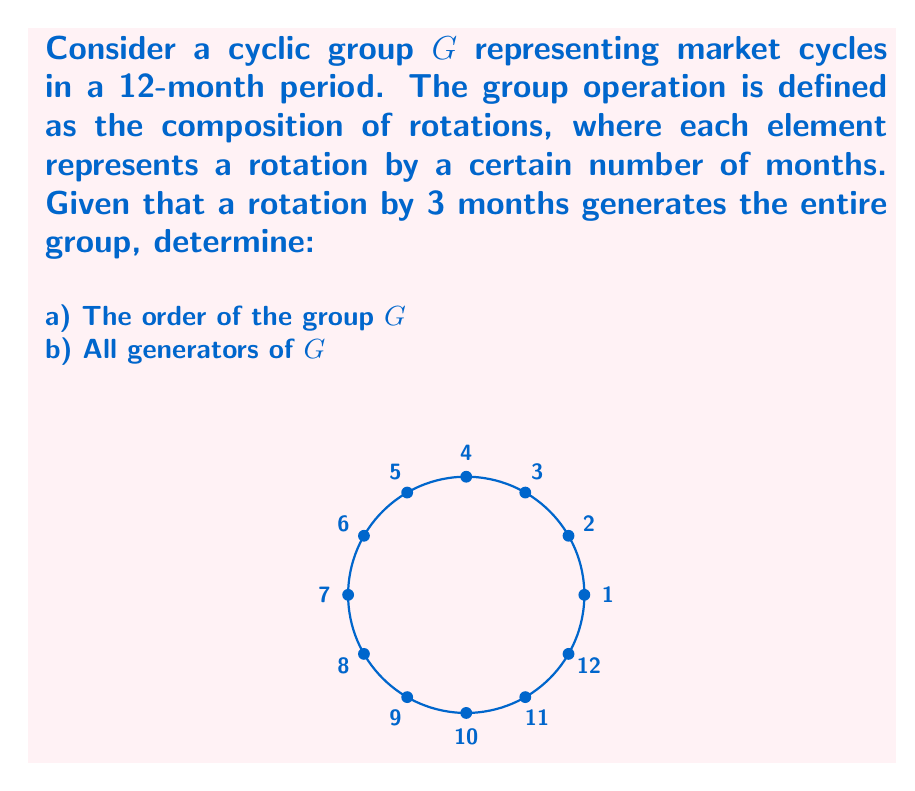Help me with this question. Let's approach this step-by-step:

1) First, we need to understand what it means for a rotation by 3 months to generate the entire group. This implies that by repeatedly applying this rotation, we can reach all elements of the group.

2) To find the order of the group:
   - Let $r$ be the rotation by 3 months.
   - We apply $r$ repeatedly until we get back to the starting point:
     $r, r^2, r^3, r^4 = $ rotations by 3, 6, 9, 12 months respectively.
   - $r^4$ brings us back to the starting point (12 months is a full cycle).

3) Therefore, the order of the group is 4. We can denote this as $|G| = 4$.

4) To find all generators, we need to find all elements that can generate the entire group when applied repeatedly.

5) Let's check each possible rotation:
   - Rotation by 1 month: $1 \to 2 \to 3 \to 4 \to 5 \to 6 \to 7 \to 8 \to 9 \to 10 \to 11 \to 12 \to 1$
     This generates the whole group, so it's a generator.
   - Rotation by 2 months: $1 \to 3 \to 5 \to 7 \to 9 \to 11 \to 1$
     This doesn't generate the whole group.
   - Rotation by 3 months: $1 \to 4 \to 7 \to 10 \to 1$
     This generates the whole group, so it's a generator.
   - Rotation by 4 months: $1 \to 5 \to 9 \to 1$
     This doesn't generate the whole group.
   - Rotation by 5 months: $1 \to 6 \to 11 \to 4 \to 9 \to 2 \to 7 \to 12 \to 5 \to 10 \to 3 \to 8 \to 1$
     This generates the whole group, so it's a generator.

6) Therefore, the generators of $G$ are rotations by 1, 3, 5, 7, 9, and 11 months.
Answer: a) $|G| = 4$
b) Generators: $\{1, 3, 5, 7, 9, 11\}$ 